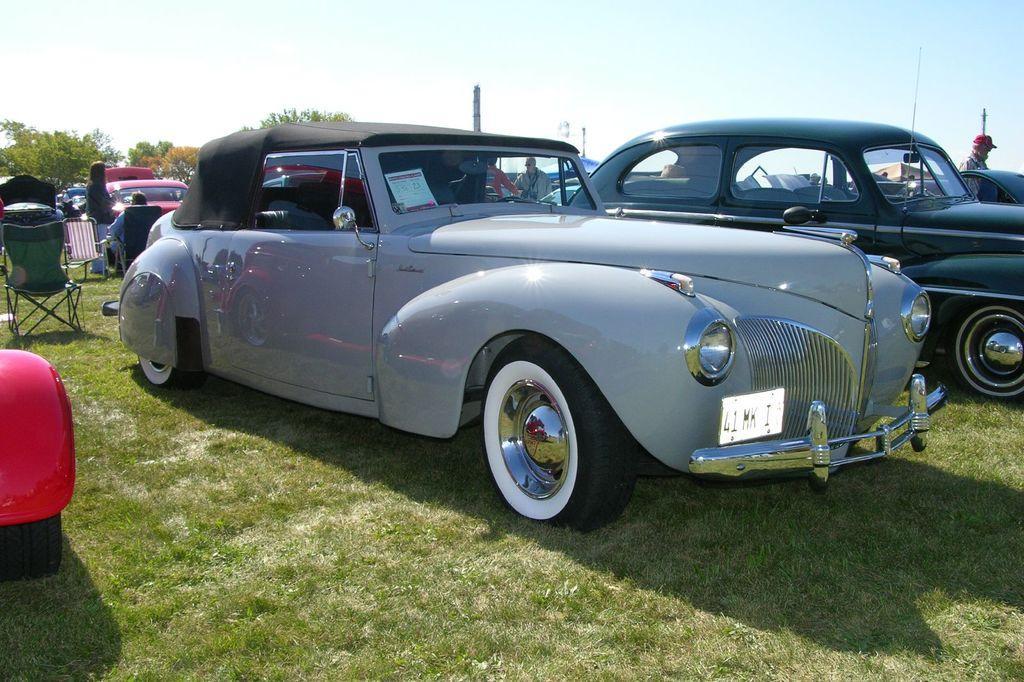How would you summarize this image in a sentence or two? In this image, there are cars on the grass. On the right side of the image, I can see a person standing. On the left side of the image, there are chairs. I can see few people. In the background, there are trees and the sky. 